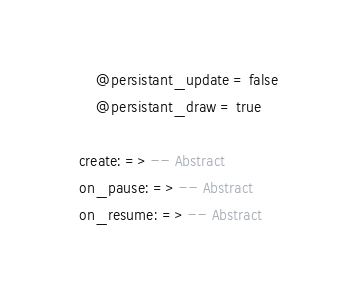Convert code to text. <code><loc_0><loc_0><loc_500><loc_500><_MoonScript_>		@persistant_update = false
		@persistant_draw = true

	create: => -- Abstract
	on_pause: => -- Abstract
	on_resume: => -- Abstract</code> 